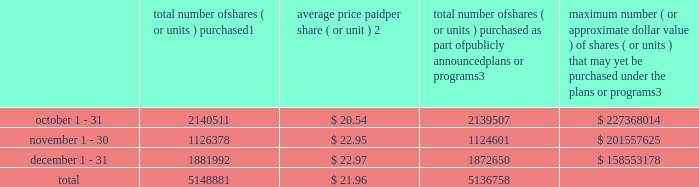Transfer agent and registrar for common stock the transfer agent and registrar for our common stock is : computershare shareowner services llc 480 washington boulevard 29th floor jersey city , new jersey 07310 telephone : ( 877 ) 363-6398 sales of unregistered securities not applicable .
Repurchase of equity securities the table provides information regarding our purchases of our equity securities during the period from october 1 , 2015 to december 31 , 2015 .
Total number of shares ( or units ) purchased 1 average price paid per share ( or unit ) 2 total number of shares ( or units ) purchased as part of publicly announced plans or programs 3 maximum number ( or approximate dollar value ) of shares ( or units ) that may yet be purchased under the plans or programs 3 .
1 included shares of our common stock , par value $ 0.10 per share , withheld under the terms of grants under employee stock-based compensation plans to offset tax withholding obligations that occurred upon vesting and release of restricted shares ( the 201cwithheld shares 201d ) .
We repurchased 1004 withheld shares in october 2015 , 1777 withheld shares in november 2015 and 9342 withheld shares in december 2015 .
2 the average price per share for each of the months in the fiscal quarter and for the three-month period was calculated by dividing the sum of the applicable period of the aggregate value of the tax withholding obligations and the aggregate amount we paid for shares acquired under our stock repurchase program , described in note 5 to the consolidated financial statements , by the sum of the number of withheld shares and the number of shares acquired in our stock repurchase program .
3 in february 2015 , the board authorized a share repurchase program to repurchase from time to time up to $ 300.0 million , excluding fees , of our common stock ( the 201c2015 share repurchase program 201d ) .
On february 12 , 2016 , we announced that our board had approved a new share repurchase program to repurchase from time to time up to $ 300.0 million , excluding fees , of our common stock .
The new authorization is in addition to any amounts remaining for repurchase under the 2015 share repurchase program .
There is no expiration date associated with the share repurchase programs. .
What percentage of total shares purchased was purchased in december? 
Computations: ((1881992 / 5148881) * 100)
Answer: 36.55148. 